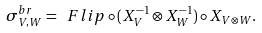<formula> <loc_0><loc_0><loc_500><loc_500>\sigma ^ { b r } _ { V , W } = \ F l i p \circ ( X _ { V } ^ { - 1 } \otimes X _ { W } ^ { - 1 } ) \circ X _ { V \otimes W } .</formula> 